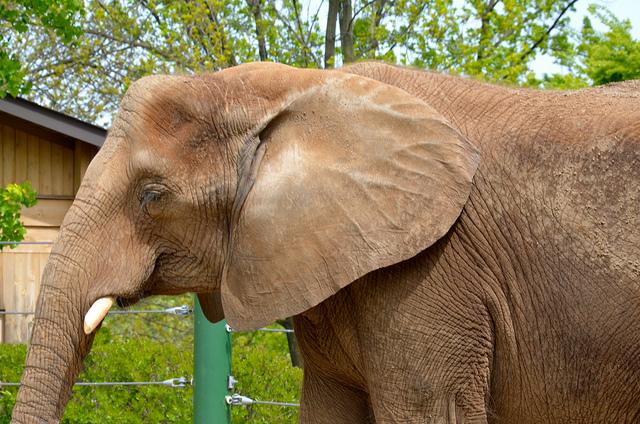Is this animal wrinkly?
Concise answer only. Yes. What kind of animal is in the photo?
Give a very brief answer. Elephant. How long are the animals tusks?
Concise answer only. Short. 